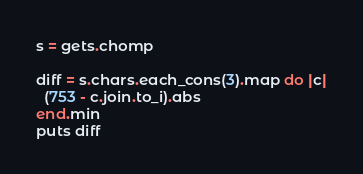Convert code to text. <code><loc_0><loc_0><loc_500><loc_500><_Ruby_>s = gets.chomp

diff = s.chars.each_cons(3).map do |c|
  (753 - c.join.to_i).abs
end.min
puts diff
</code> 